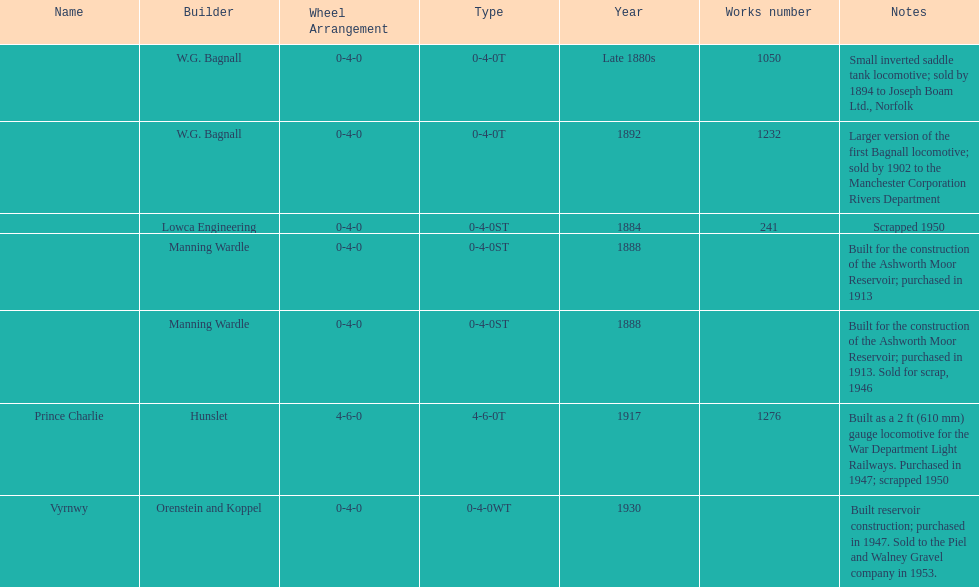How many locomotives were built for the construction of the ashworth moor reservoir? 2. 